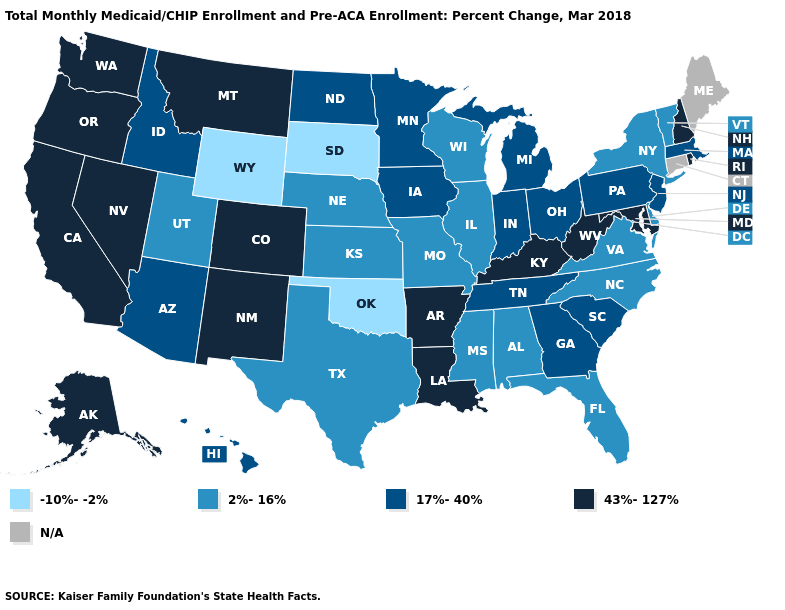Does Oregon have the highest value in the West?
Write a very short answer. Yes. Name the states that have a value in the range 43%-127%?
Quick response, please. Alaska, Arkansas, California, Colorado, Kentucky, Louisiana, Maryland, Montana, Nevada, New Hampshire, New Mexico, Oregon, Rhode Island, Washington, West Virginia. What is the value of Mississippi?
Write a very short answer. 2%-16%. What is the value of Maryland?
Give a very brief answer. 43%-127%. Among the states that border Kansas , which have the highest value?
Write a very short answer. Colorado. What is the value of Mississippi?
Concise answer only. 2%-16%. Among the states that border California , which have the highest value?
Write a very short answer. Nevada, Oregon. What is the value of Connecticut?
Give a very brief answer. N/A. Name the states that have a value in the range N/A?
Give a very brief answer. Connecticut, Maine. What is the value of Hawaii?
Write a very short answer. 17%-40%. Which states have the lowest value in the West?
Write a very short answer. Wyoming. Name the states that have a value in the range N/A?
Keep it brief. Connecticut, Maine. Among the states that border Wisconsin , which have the lowest value?
Quick response, please. Illinois. 